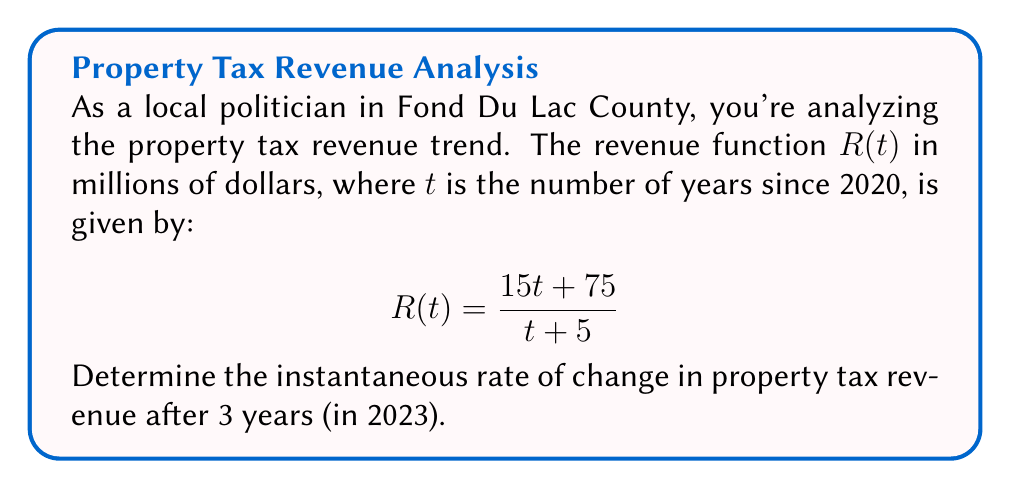Can you answer this question? To find the instantaneous rate of change, we need to calculate the derivative of the revenue function $R(t)$ and evaluate it at $t=3$.

Step 1: Calculate the derivative of $R(t)$ using the quotient rule.
Let $u = 15t + 75$ and $v = t + 5$
$$R'(t) = \frac{u'v - uv'}{v^2} = \frac{15(t+5) - (15t+75)(1)}{(t+5)^2}$$

Step 2: Simplify the numerator.
$$R'(t) = \frac{15t + 75 - 15t - 75}{(t+5)^2} = \frac{0}{(t+5)^2}$$

Step 3: Further simplify.
$$R'(t) = \frac{0}{(t+5)^2}$$

Step 4: Evaluate $R'(t)$ at $t=3$.
$$R'(3) = \frac{0}{(3+5)^2} = \frac{0}{64} = 0$$

The instantaneous rate of change is 0 million dollars per year.
Answer: $0$ million dollars per year 